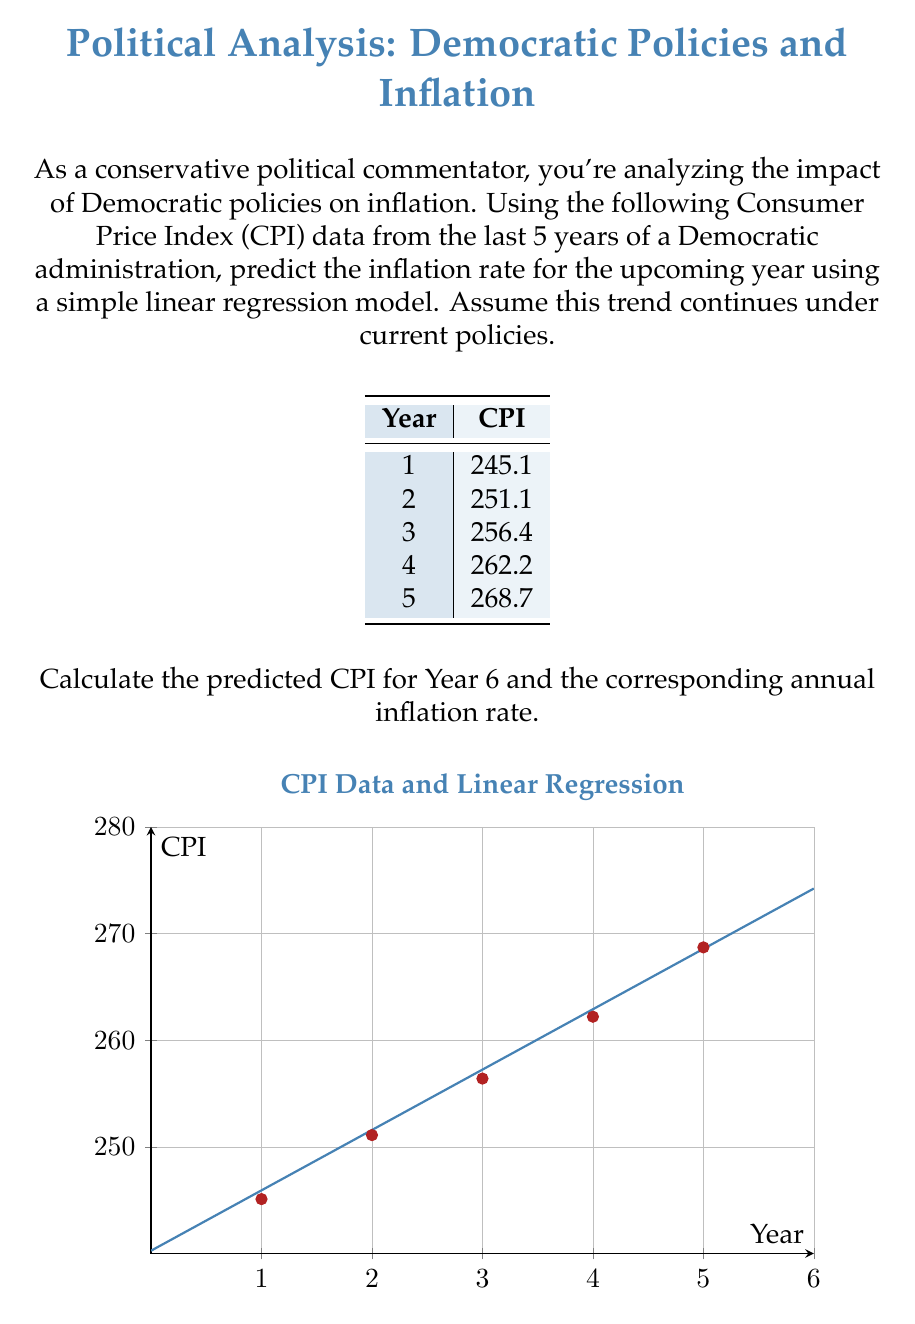Can you solve this math problem? To solve this problem, we'll use simple linear regression to predict the CPI for Year 6 and then calculate the inflation rate.

Step 1: Calculate the slope (m) and y-intercept (b) for the linear regression line.
Using the formula: $y = mx + b$

We can calculate these values:
$m = \frac{\sum_{i=1}^{n} (x_i - \bar{x})(y_i - \bar{y})}{\sum_{i=1}^{n} (x_i - \bar{x})^2} \approx 5.66$
$b = \bar{y} - m\bar{x} \approx 240.26$

Step 2: Use the linear equation to predict CPI for Year 6
$CPI_6 = mx + b = 5.66 * 6 + 240.26 = 274.22$

Step 3: Calculate the inflation rate
Inflation rate is typically calculated as the percentage change in CPI from one year to the next.

$\text{Inflation Rate} = \frac{CPI_6 - CPI_5}{CPI_5} * 100\%$

$= \frac{274.22 - 268.7}{268.7} * 100\% \approx 2.05\%$

This result suggests that if the trend under current Democratic policies continues, we can expect an inflation rate of approximately 2.05% in the coming year.
Answer: Predicted CPI for Year 6: 274.22; Predicted inflation rate: 2.05% 